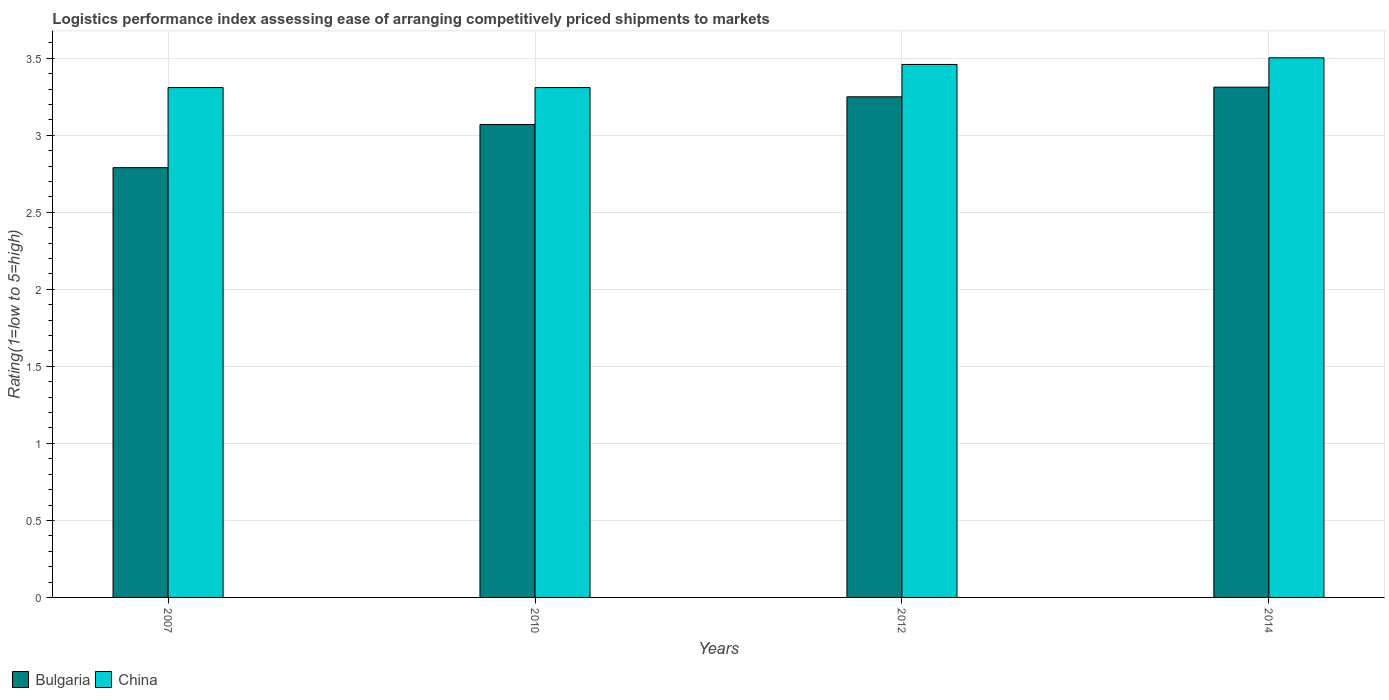How many different coloured bars are there?
Provide a succinct answer. 2. How many groups of bars are there?
Your answer should be very brief. 4. How many bars are there on the 4th tick from the left?
Ensure brevity in your answer.  2. In how many cases, is the number of bars for a given year not equal to the number of legend labels?
Offer a terse response. 0. What is the Logistic performance index in China in 2010?
Offer a terse response. 3.31. Across all years, what is the maximum Logistic performance index in Bulgaria?
Offer a terse response. 3.31. Across all years, what is the minimum Logistic performance index in China?
Provide a short and direct response. 3.31. In which year was the Logistic performance index in China maximum?
Your answer should be very brief. 2014. In which year was the Logistic performance index in China minimum?
Your answer should be very brief. 2007. What is the total Logistic performance index in Bulgaria in the graph?
Give a very brief answer. 12.42. What is the difference between the Logistic performance index in China in 2012 and that in 2014?
Give a very brief answer. -0.04. What is the difference between the Logistic performance index in China in 2007 and the Logistic performance index in Bulgaria in 2012?
Your answer should be very brief. 0.06. What is the average Logistic performance index in Bulgaria per year?
Offer a very short reply. 3.11. In the year 2014, what is the difference between the Logistic performance index in China and Logistic performance index in Bulgaria?
Ensure brevity in your answer.  0.19. In how many years, is the Logistic performance index in Bulgaria greater than 1.4?
Your answer should be very brief. 4. What is the ratio of the Logistic performance index in Bulgaria in 2007 to that in 2010?
Give a very brief answer. 0.91. What is the difference between the highest and the second highest Logistic performance index in China?
Ensure brevity in your answer.  0.04. What is the difference between the highest and the lowest Logistic performance index in Bulgaria?
Your answer should be compact. 0.52. In how many years, is the Logistic performance index in Bulgaria greater than the average Logistic performance index in Bulgaria taken over all years?
Make the answer very short. 2. What does the 1st bar from the right in 2007 represents?
Provide a succinct answer. China. How many bars are there?
Keep it short and to the point. 8. How many years are there in the graph?
Ensure brevity in your answer.  4. What is the difference between two consecutive major ticks on the Y-axis?
Ensure brevity in your answer.  0.5. Are the values on the major ticks of Y-axis written in scientific E-notation?
Offer a very short reply. No. Does the graph contain any zero values?
Your response must be concise. No. How many legend labels are there?
Offer a very short reply. 2. How are the legend labels stacked?
Give a very brief answer. Horizontal. What is the title of the graph?
Your answer should be compact. Logistics performance index assessing ease of arranging competitively priced shipments to markets. What is the label or title of the X-axis?
Offer a terse response. Years. What is the label or title of the Y-axis?
Give a very brief answer. Rating(1=low to 5=high). What is the Rating(1=low to 5=high) of Bulgaria in 2007?
Your answer should be compact. 2.79. What is the Rating(1=low to 5=high) in China in 2007?
Provide a short and direct response. 3.31. What is the Rating(1=low to 5=high) of Bulgaria in 2010?
Your response must be concise. 3.07. What is the Rating(1=low to 5=high) in China in 2010?
Offer a terse response. 3.31. What is the Rating(1=low to 5=high) in China in 2012?
Your answer should be compact. 3.46. What is the Rating(1=low to 5=high) of Bulgaria in 2014?
Provide a short and direct response. 3.31. What is the Rating(1=low to 5=high) in China in 2014?
Provide a succinct answer. 3.5. Across all years, what is the maximum Rating(1=low to 5=high) of Bulgaria?
Provide a succinct answer. 3.31. Across all years, what is the maximum Rating(1=low to 5=high) in China?
Offer a terse response. 3.5. Across all years, what is the minimum Rating(1=low to 5=high) in Bulgaria?
Your response must be concise. 2.79. Across all years, what is the minimum Rating(1=low to 5=high) of China?
Keep it short and to the point. 3.31. What is the total Rating(1=low to 5=high) of Bulgaria in the graph?
Give a very brief answer. 12.42. What is the total Rating(1=low to 5=high) in China in the graph?
Provide a succinct answer. 13.58. What is the difference between the Rating(1=low to 5=high) in Bulgaria in 2007 and that in 2010?
Your response must be concise. -0.28. What is the difference between the Rating(1=low to 5=high) of China in 2007 and that in 2010?
Provide a succinct answer. 0. What is the difference between the Rating(1=low to 5=high) of Bulgaria in 2007 and that in 2012?
Your answer should be compact. -0.46. What is the difference between the Rating(1=low to 5=high) in Bulgaria in 2007 and that in 2014?
Your response must be concise. -0.52. What is the difference between the Rating(1=low to 5=high) in China in 2007 and that in 2014?
Keep it short and to the point. -0.19. What is the difference between the Rating(1=low to 5=high) in Bulgaria in 2010 and that in 2012?
Offer a terse response. -0.18. What is the difference between the Rating(1=low to 5=high) in China in 2010 and that in 2012?
Provide a succinct answer. -0.15. What is the difference between the Rating(1=low to 5=high) in Bulgaria in 2010 and that in 2014?
Your answer should be very brief. -0.24. What is the difference between the Rating(1=low to 5=high) in China in 2010 and that in 2014?
Offer a terse response. -0.19. What is the difference between the Rating(1=low to 5=high) of Bulgaria in 2012 and that in 2014?
Your answer should be compact. -0.06. What is the difference between the Rating(1=low to 5=high) in China in 2012 and that in 2014?
Give a very brief answer. -0.04. What is the difference between the Rating(1=low to 5=high) in Bulgaria in 2007 and the Rating(1=low to 5=high) in China in 2010?
Give a very brief answer. -0.52. What is the difference between the Rating(1=low to 5=high) of Bulgaria in 2007 and the Rating(1=low to 5=high) of China in 2012?
Your answer should be very brief. -0.67. What is the difference between the Rating(1=low to 5=high) of Bulgaria in 2007 and the Rating(1=low to 5=high) of China in 2014?
Ensure brevity in your answer.  -0.71. What is the difference between the Rating(1=low to 5=high) of Bulgaria in 2010 and the Rating(1=low to 5=high) of China in 2012?
Provide a succinct answer. -0.39. What is the difference between the Rating(1=low to 5=high) of Bulgaria in 2010 and the Rating(1=low to 5=high) of China in 2014?
Give a very brief answer. -0.43. What is the difference between the Rating(1=low to 5=high) of Bulgaria in 2012 and the Rating(1=low to 5=high) of China in 2014?
Make the answer very short. -0.25. What is the average Rating(1=low to 5=high) of Bulgaria per year?
Offer a very short reply. 3.11. What is the average Rating(1=low to 5=high) in China per year?
Offer a very short reply. 3.4. In the year 2007, what is the difference between the Rating(1=low to 5=high) of Bulgaria and Rating(1=low to 5=high) of China?
Your response must be concise. -0.52. In the year 2010, what is the difference between the Rating(1=low to 5=high) in Bulgaria and Rating(1=low to 5=high) in China?
Offer a terse response. -0.24. In the year 2012, what is the difference between the Rating(1=low to 5=high) of Bulgaria and Rating(1=low to 5=high) of China?
Provide a succinct answer. -0.21. In the year 2014, what is the difference between the Rating(1=low to 5=high) of Bulgaria and Rating(1=low to 5=high) of China?
Provide a short and direct response. -0.19. What is the ratio of the Rating(1=low to 5=high) in Bulgaria in 2007 to that in 2010?
Your answer should be very brief. 0.91. What is the ratio of the Rating(1=low to 5=high) of China in 2007 to that in 2010?
Your response must be concise. 1. What is the ratio of the Rating(1=low to 5=high) in Bulgaria in 2007 to that in 2012?
Your response must be concise. 0.86. What is the ratio of the Rating(1=low to 5=high) of China in 2007 to that in 2012?
Provide a short and direct response. 0.96. What is the ratio of the Rating(1=low to 5=high) in Bulgaria in 2007 to that in 2014?
Make the answer very short. 0.84. What is the ratio of the Rating(1=low to 5=high) in China in 2007 to that in 2014?
Your answer should be compact. 0.94. What is the ratio of the Rating(1=low to 5=high) in Bulgaria in 2010 to that in 2012?
Provide a succinct answer. 0.94. What is the ratio of the Rating(1=low to 5=high) in China in 2010 to that in 2012?
Give a very brief answer. 0.96. What is the ratio of the Rating(1=low to 5=high) in Bulgaria in 2010 to that in 2014?
Offer a very short reply. 0.93. What is the ratio of the Rating(1=low to 5=high) in China in 2010 to that in 2014?
Keep it short and to the point. 0.94. What is the ratio of the Rating(1=low to 5=high) in Bulgaria in 2012 to that in 2014?
Make the answer very short. 0.98. What is the ratio of the Rating(1=low to 5=high) of China in 2012 to that in 2014?
Give a very brief answer. 0.99. What is the difference between the highest and the second highest Rating(1=low to 5=high) in Bulgaria?
Make the answer very short. 0.06. What is the difference between the highest and the second highest Rating(1=low to 5=high) in China?
Give a very brief answer. 0.04. What is the difference between the highest and the lowest Rating(1=low to 5=high) of Bulgaria?
Provide a succinct answer. 0.52. What is the difference between the highest and the lowest Rating(1=low to 5=high) in China?
Offer a terse response. 0.19. 